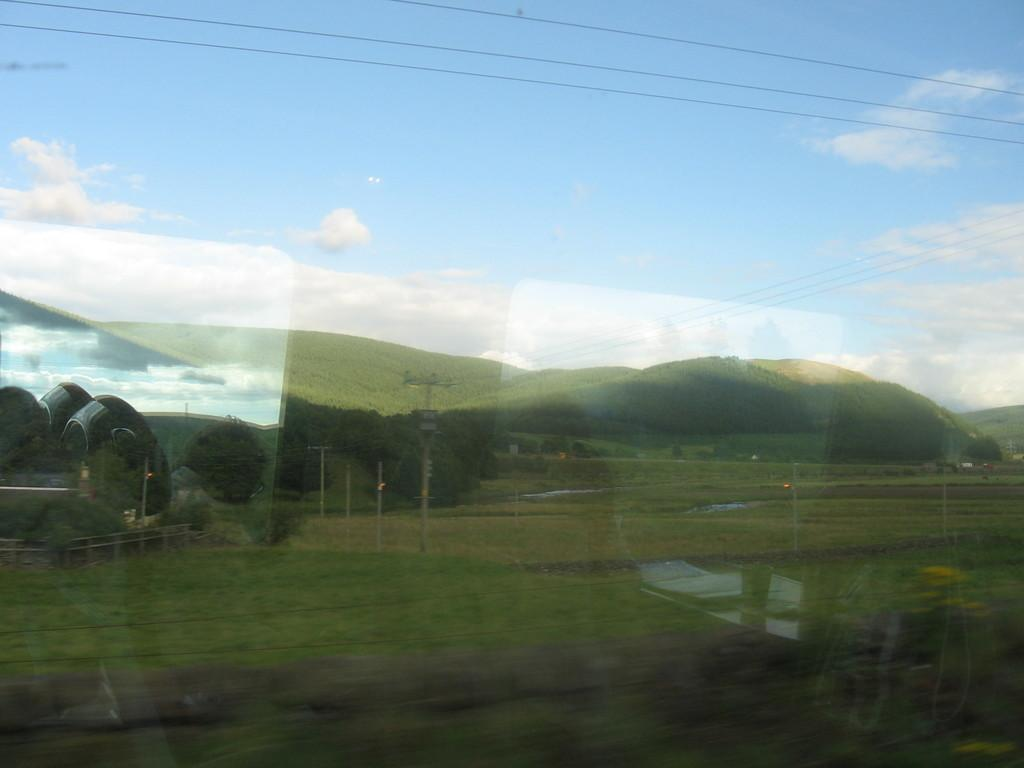What object is present in the image that has a transparent or translucent surface? There is a glass in the image. What can be seen through the glass? Grass, trees, poles, wires, and the sky are visible through the glass. How many twigs can be seen on the feet of the person in the image? There is no person present in the image, and therefore no feet or twigs can be observed. What type of ring is visible on the person's finger in the image? There is no person present in the image, and therefore no ring can be observed. 